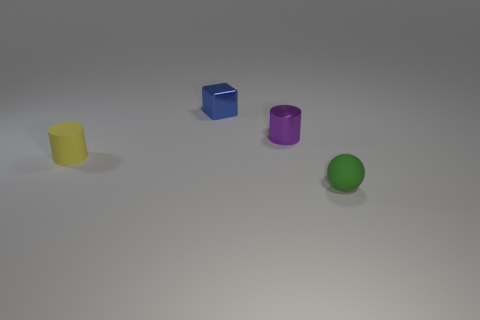What number of tiny cylinders are both on the right side of the blue thing and in front of the shiny cylinder?
Provide a short and direct response. 0. What material is the cylinder left of the small cylinder behind the matte cylinder?
Offer a terse response. Rubber. Is there a big thing made of the same material as the small green ball?
Ensure brevity in your answer.  No. What material is the blue block that is the same size as the yellow rubber cylinder?
Ensure brevity in your answer.  Metal. There is a rubber thing behind the tiny object that is in front of the cylinder that is on the left side of the purple metallic object; what is its size?
Your answer should be compact. Small. There is a matte object that is to the left of the blue block; is there a small metallic thing that is behind it?
Offer a terse response. Yes. There is a small green thing; does it have the same shape as the metallic object that is on the left side of the shiny cylinder?
Provide a succinct answer. No. There is a small object that is to the right of the purple object; what color is it?
Your answer should be very brief. Green. There is a rubber thing in front of the small thing that is on the left side of the blue shiny thing; what size is it?
Keep it short and to the point. Small. Do the matte object that is to the left of the tiny rubber sphere and the tiny purple object have the same shape?
Provide a succinct answer. Yes. 